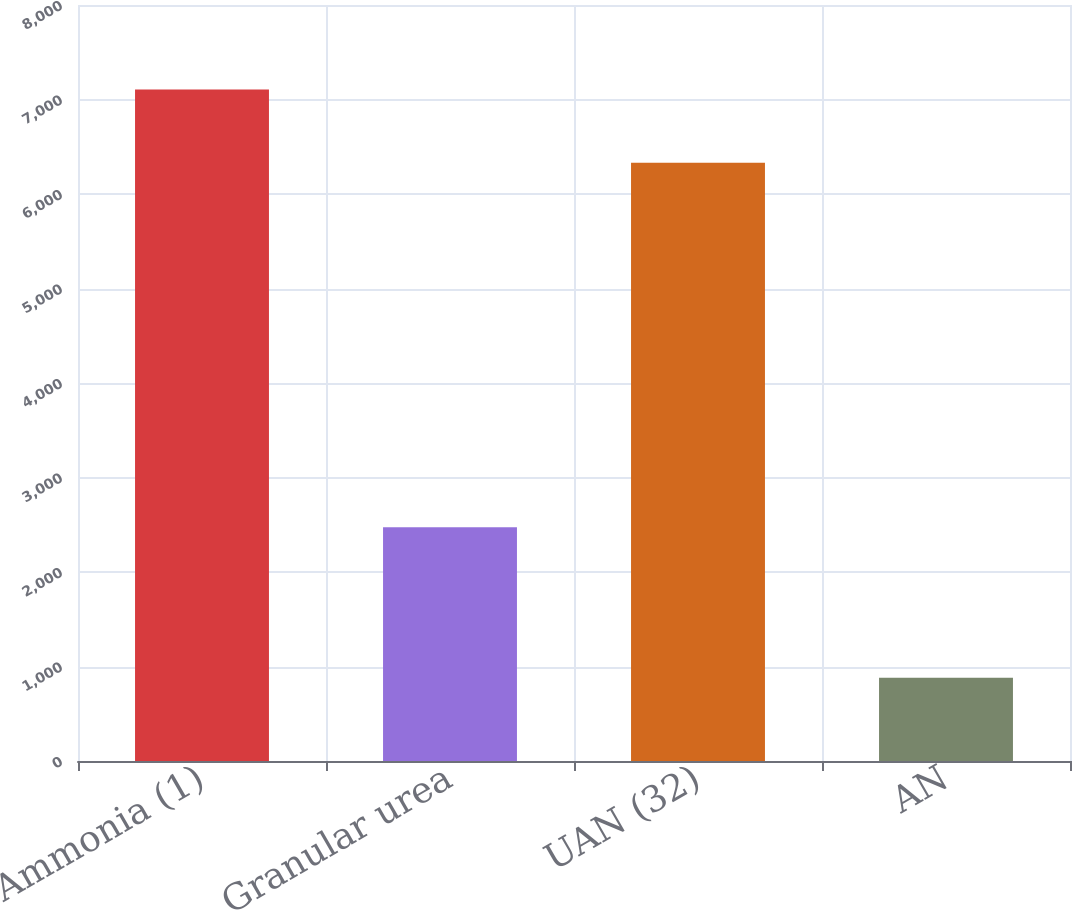Convert chart. <chart><loc_0><loc_0><loc_500><loc_500><bar_chart><fcel>Ammonia (1)<fcel>Granular urea<fcel>UAN (32)<fcel>AN<nl><fcel>7105<fcel>2474<fcel>6332<fcel>882<nl></chart> 